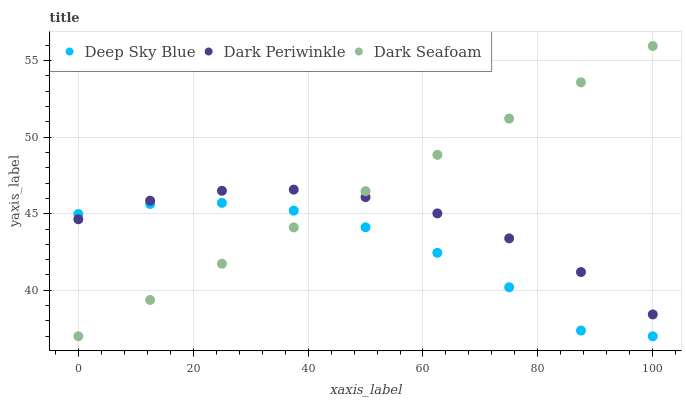Does Deep Sky Blue have the minimum area under the curve?
Answer yes or no. Yes. Does Dark Seafoam have the maximum area under the curve?
Answer yes or no. Yes. Does Dark Periwinkle have the minimum area under the curve?
Answer yes or no. No. Does Dark Periwinkle have the maximum area under the curve?
Answer yes or no. No. Is Dark Seafoam the smoothest?
Answer yes or no. Yes. Is Deep Sky Blue the roughest?
Answer yes or no. Yes. Is Dark Periwinkle the smoothest?
Answer yes or no. No. Is Dark Periwinkle the roughest?
Answer yes or no. No. Does Dark Seafoam have the lowest value?
Answer yes or no. Yes. Does Dark Periwinkle have the lowest value?
Answer yes or no. No. Does Dark Seafoam have the highest value?
Answer yes or no. Yes. Does Dark Periwinkle have the highest value?
Answer yes or no. No. Does Dark Periwinkle intersect Dark Seafoam?
Answer yes or no. Yes. Is Dark Periwinkle less than Dark Seafoam?
Answer yes or no. No. Is Dark Periwinkle greater than Dark Seafoam?
Answer yes or no. No. 